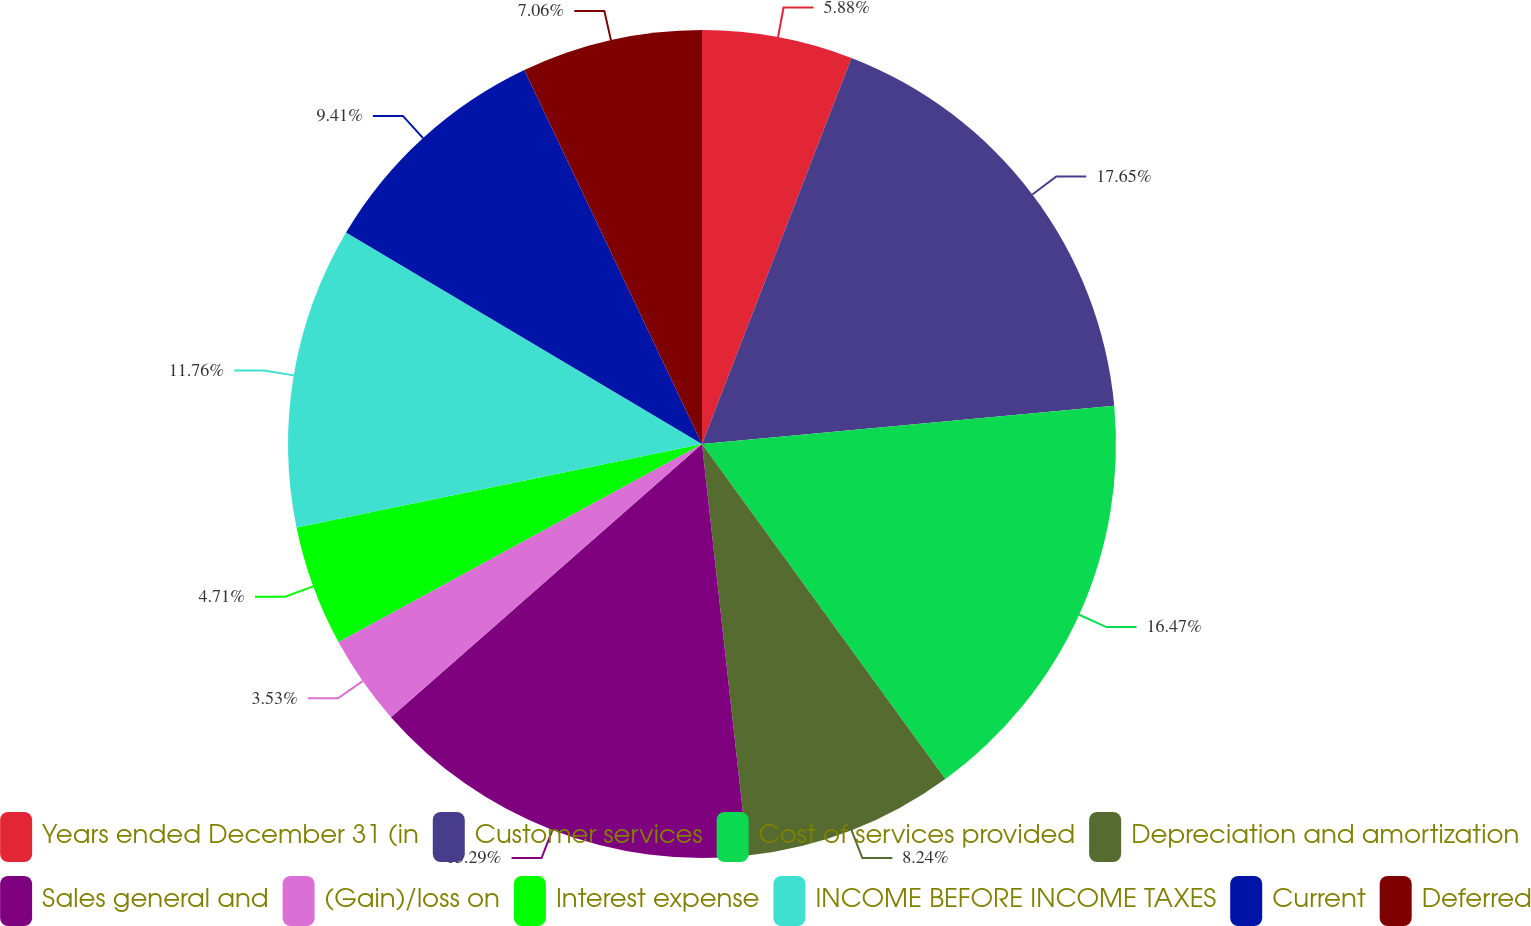Convert chart. <chart><loc_0><loc_0><loc_500><loc_500><pie_chart><fcel>Years ended December 31 (in<fcel>Customer services<fcel>Cost of services provided<fcel>Depreciation and amortization<fcel>Sales general and<fcel>(Gain)/loss on<fcel>Interest expense<fcel>INCOME BEFORE INCOME TAXES<fcel>Current<fcel>Deferred<nl><fcel>5.88%<fcel>17.65%<fcel>16.47%<fcel>8.24%<fcel>15.29%<fcel>3.53%<fcel>4.71%<fcel>11.76%<fcel>9.41%<fcel>7.06%<nl></chart> 